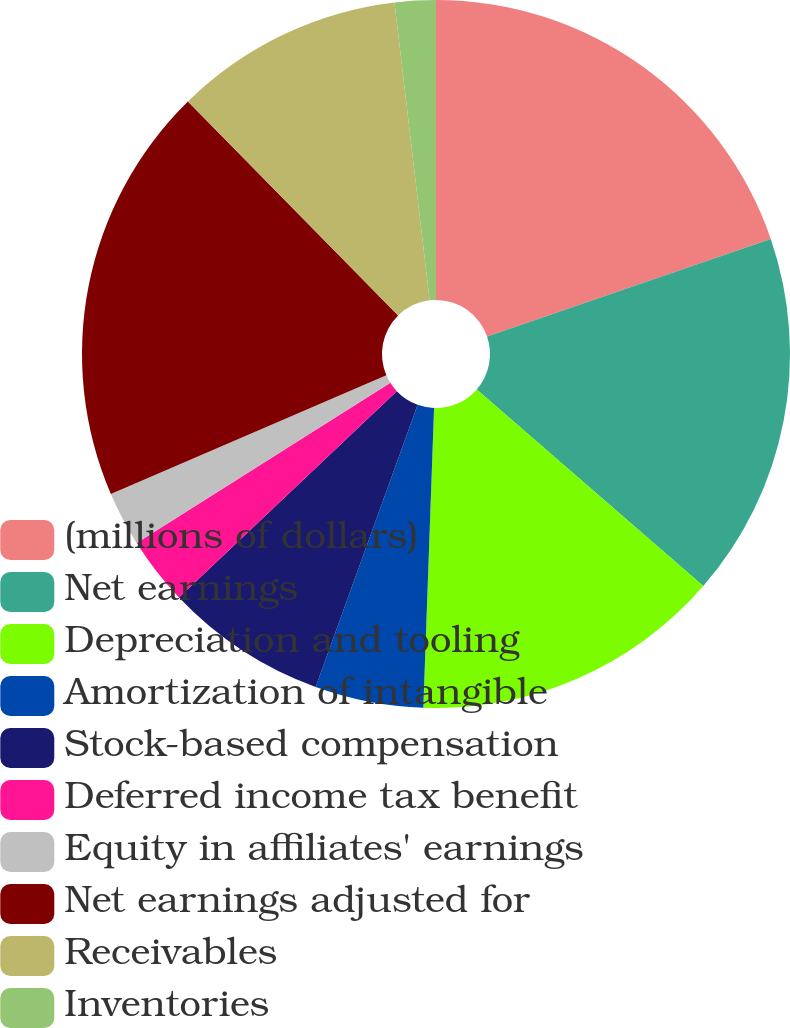<chart> <loc_0><loc_0><loc_500><loc_500><pie_chart><fcel>(millions of dollars)<fcel>Net earnings<fcel>Depreciation and tooling<fcel>Amortization of intangible<fcel>Stock-based compensation<fcel>Deferred income tax benefit<fcel>Equity in affiliates' earnings<fcel>Net earnings adjusted for<fcel>Receivables<fcel>Inventories<nl><fcel>19.73%<fcel>16.65%<fcel>14.19%<fcel>4.95%<fcel>7.41%<fcel>3.11%<fcel>2.49%<fcel>19.11%<fcel>10.49%<fcel>1.87%<nl></chart> 